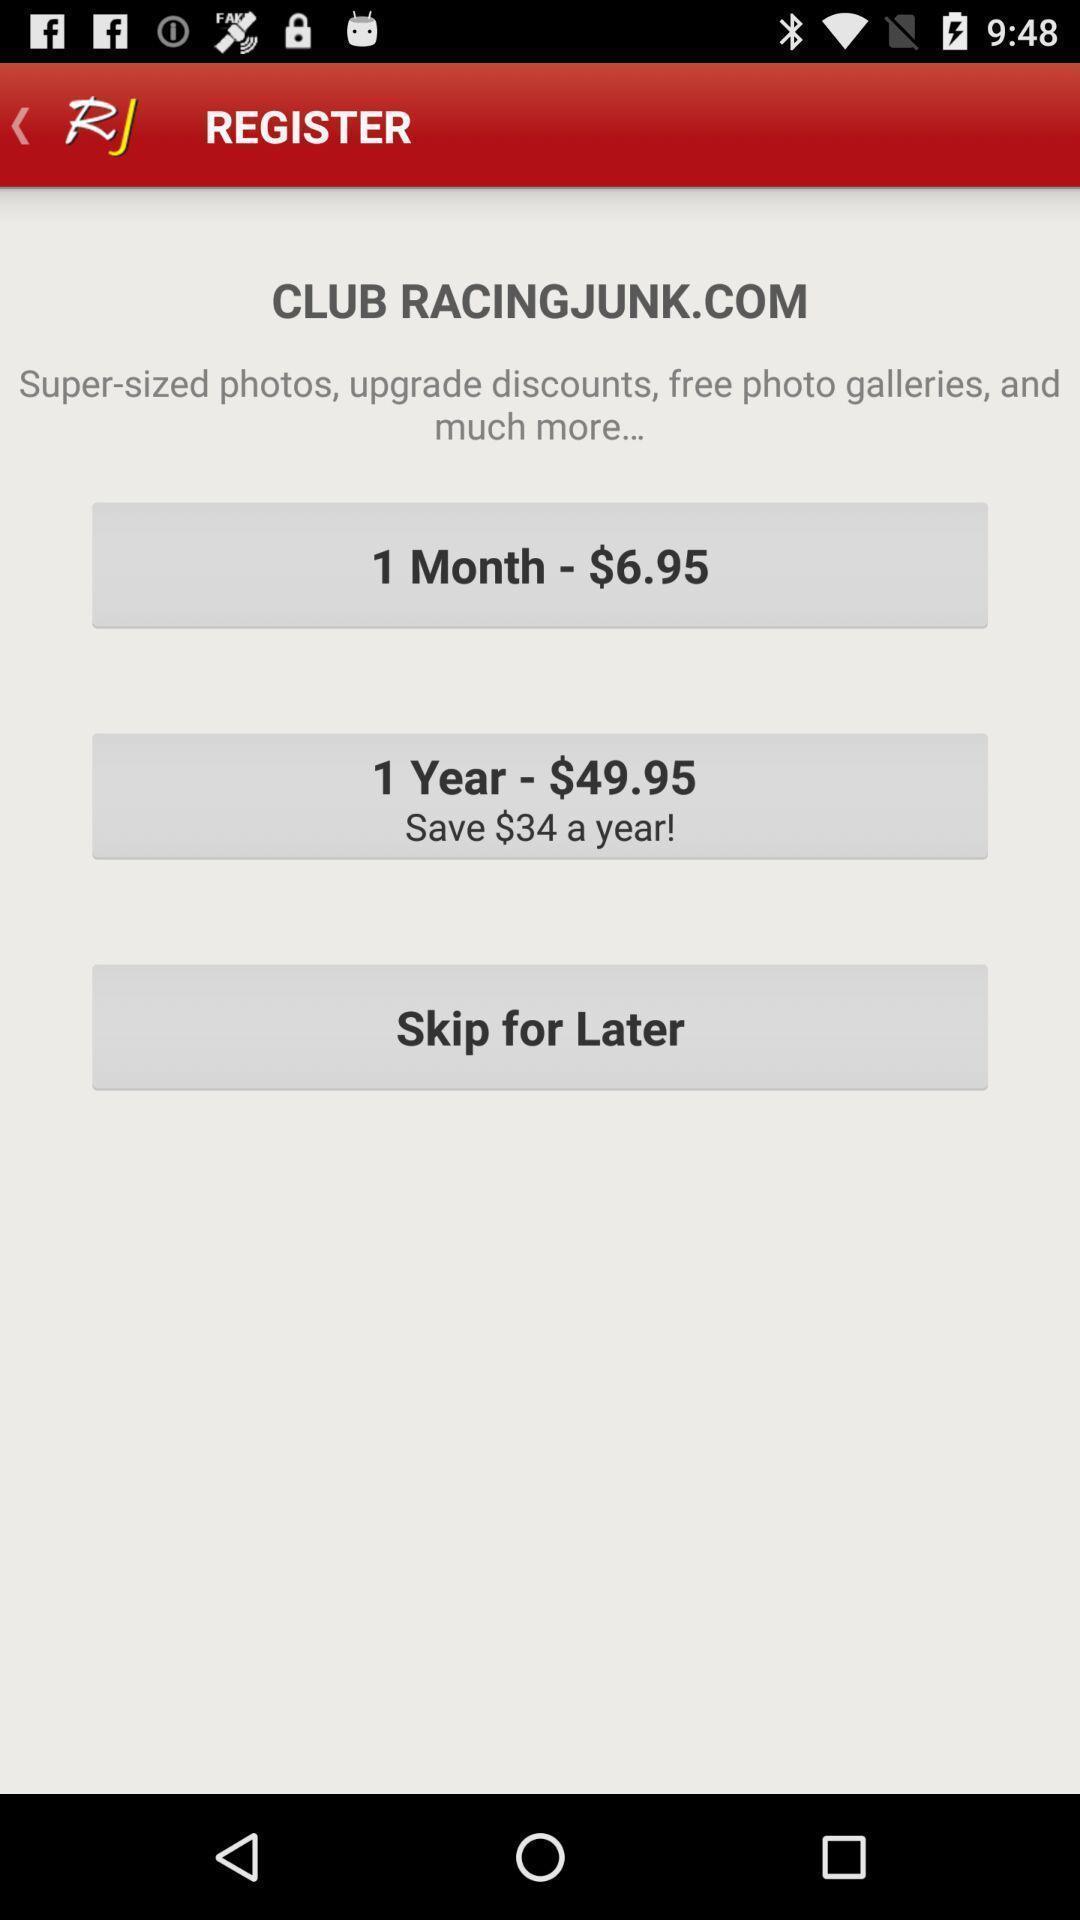Describe the visual elements of this screenshot. Website of club register in register page. 